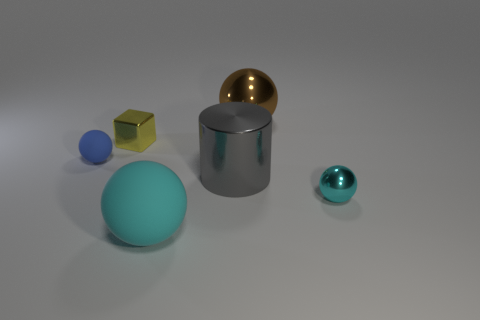Subtract all brown spheres. How many spheres are left? 3 Subtract all brown balls. How many balls are left? 3 Add 1 big gray rubber cylinders. How many objects exist? 7 Subtract all spheres. How many objects are left? 2 Subtract all red cylinders. How many green blocks are left? 0 Subtract all large blue metallic cubes. Subtract all small blue objects. How many objects are left? 5 Add 1 matte things. How many matte things are left? 3 Add 5 tiny blue rubber cylinders. How many tiny blue rubber cylinders exist? 5 Subtract 0 purple balls. How many objects are left? 6 Subtract all cyan cubes. Subtract all gray cylinders. How many cubes are left? 1 